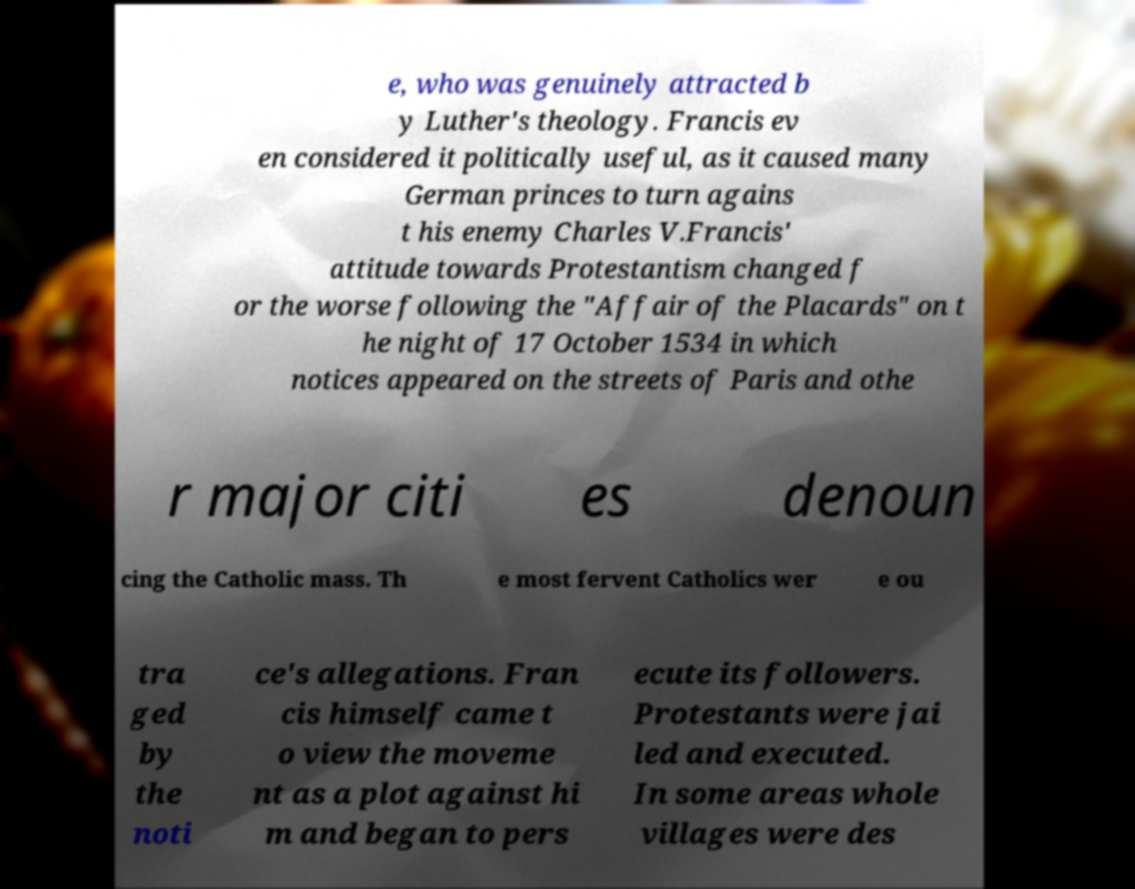What messages or text are displayed in this image? I need them in a readable, typed format. e, who was genuinely attracted b y Luther's theology. Francis ev en considered it politically useful, as it caused many German princes to turn agains t his enemy Charles V.Francis' attitude towards Protestantism changed f or the worse following the "Affair of the Placards" on t he night of 17 October 1534 in which notices appeared on the streets of Paris and othe r major citi es denoun cing the Catholic mass. Th e most fervent Catholics wer e ou tra ged by the noti ce's allegations. Fran cis himself came t o view the moveme nt as a plot against hi m and began to pers ecute its followers. Protestants were jai led and executed. In some areas whole villages were des 